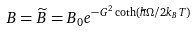<formula> <loc_0><loc_0><loc_500><loc_500>B = \widetilde { B } = B _ { 0 } e ^ { - G ^ { 2 } \coth \left ( \hbar { \Omega } / 2 k _ { B } T \right ) }</formula> 